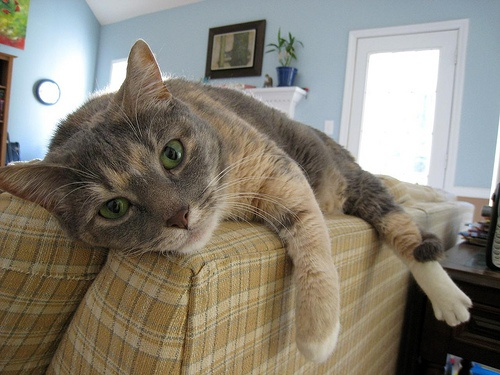Describe the objects in this image and their specific colors. I can see cat in darkgreen, gray, and black tones, couch in darkgreen, tan, olive, and gray tones, potted plant in darkgreen, gray, navy, and darkgray tones, and clock in darkgreen, white, lightblue, gray, and darkgray tones in this image. 